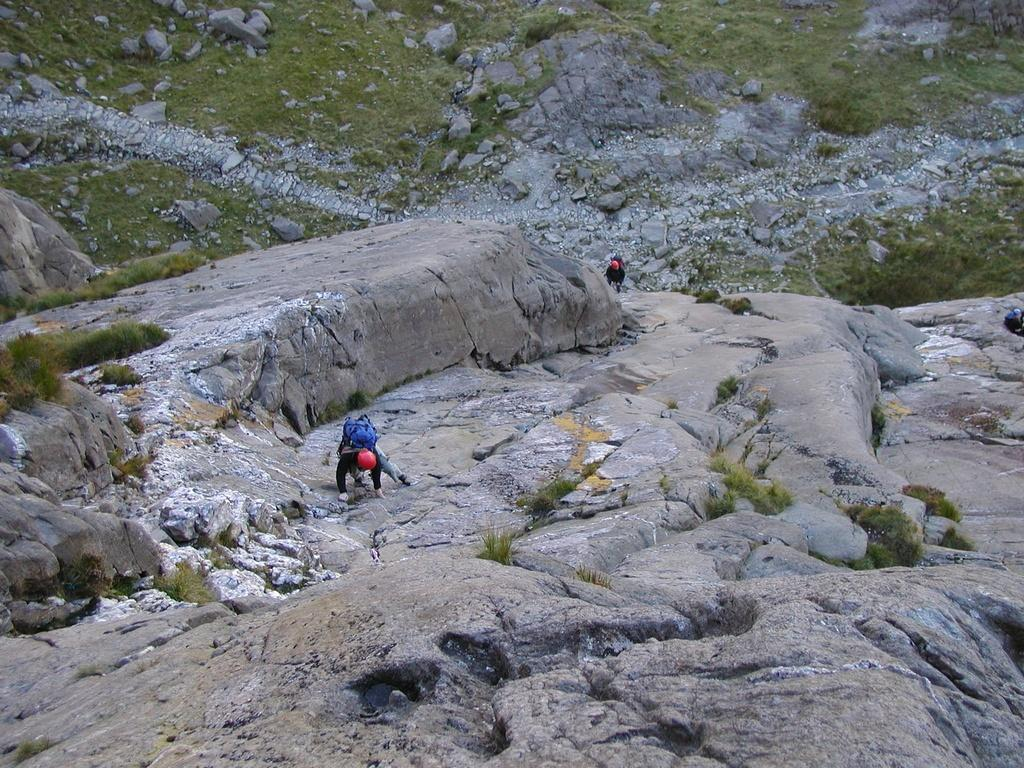Who or what is present in the image? There are people in the image. What are the people doing in the image? The people are climbing a hill. What type of terrain can be seen in the image? There are rocks and grass visible in the image. How many rings can be seen on the grass in the image? There are no rings visible in the image; only rocks and grass can be seen. 